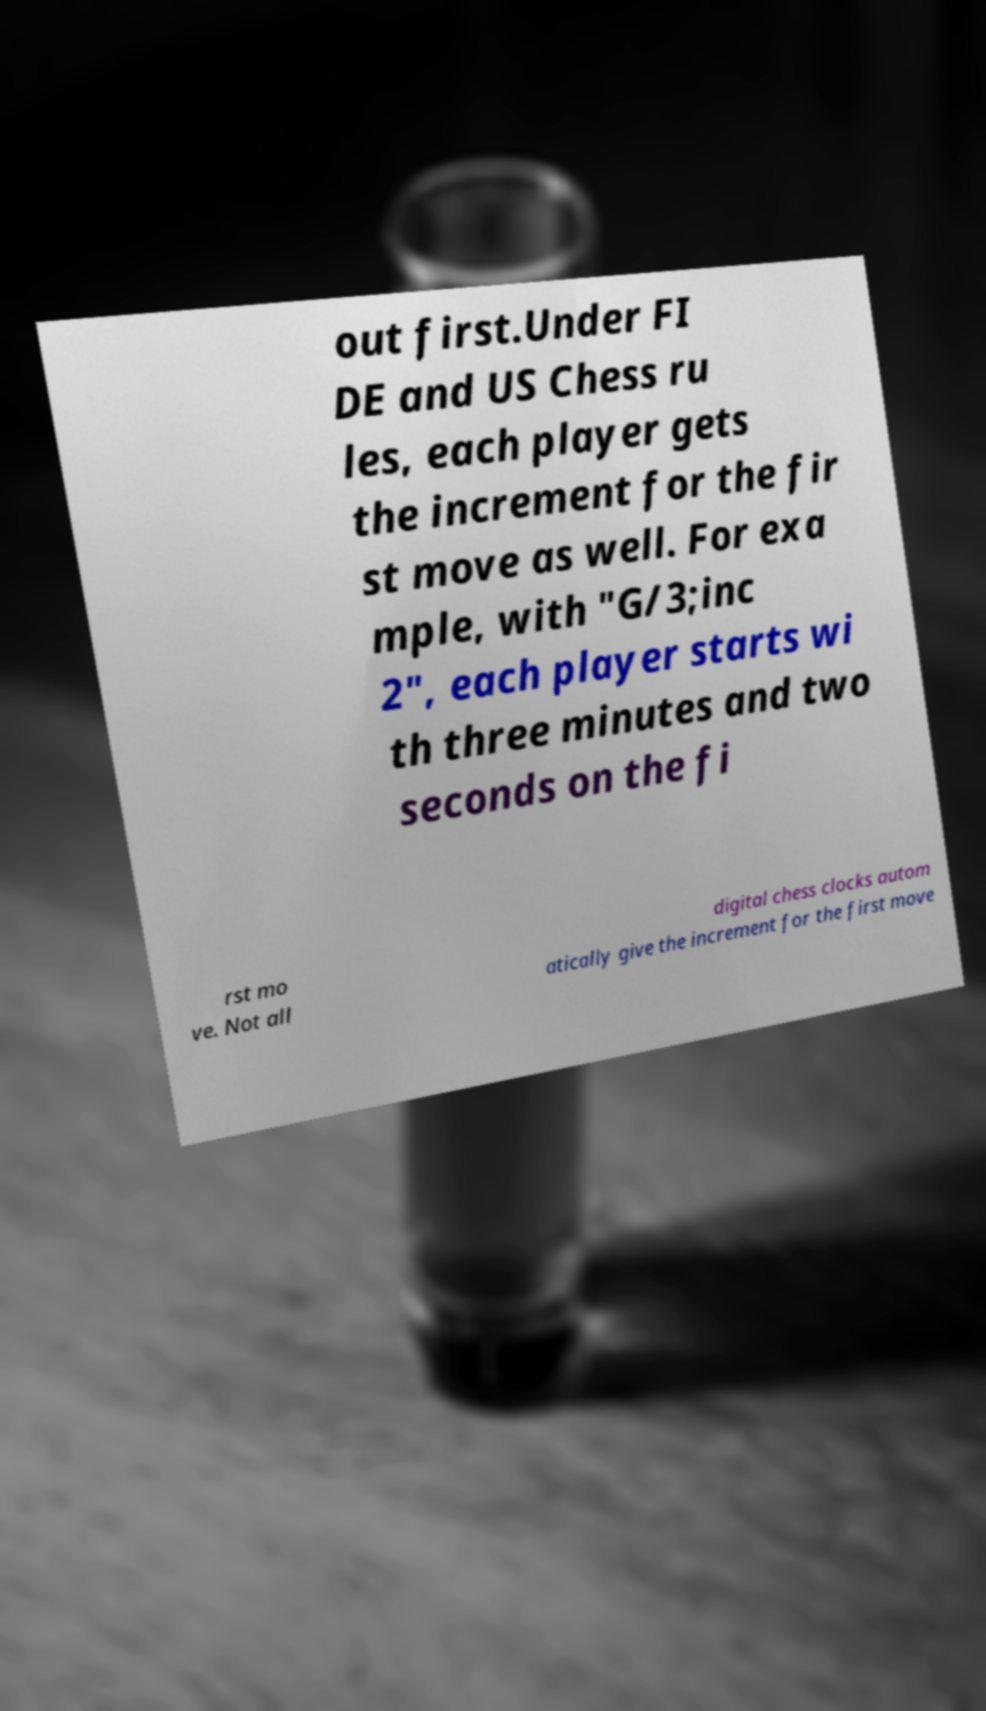Can you accurately transcribe the text from the provided image for me? out first.Under FI DE and US Chess ru les, each player gets the increment for the fir st move as well. For exa mple, with "G/3;inc 2", each player starts wi th three minutes and two seconds on the fi rst mo ve. Not all digital chess clocks autom atically give the increment for the first move 